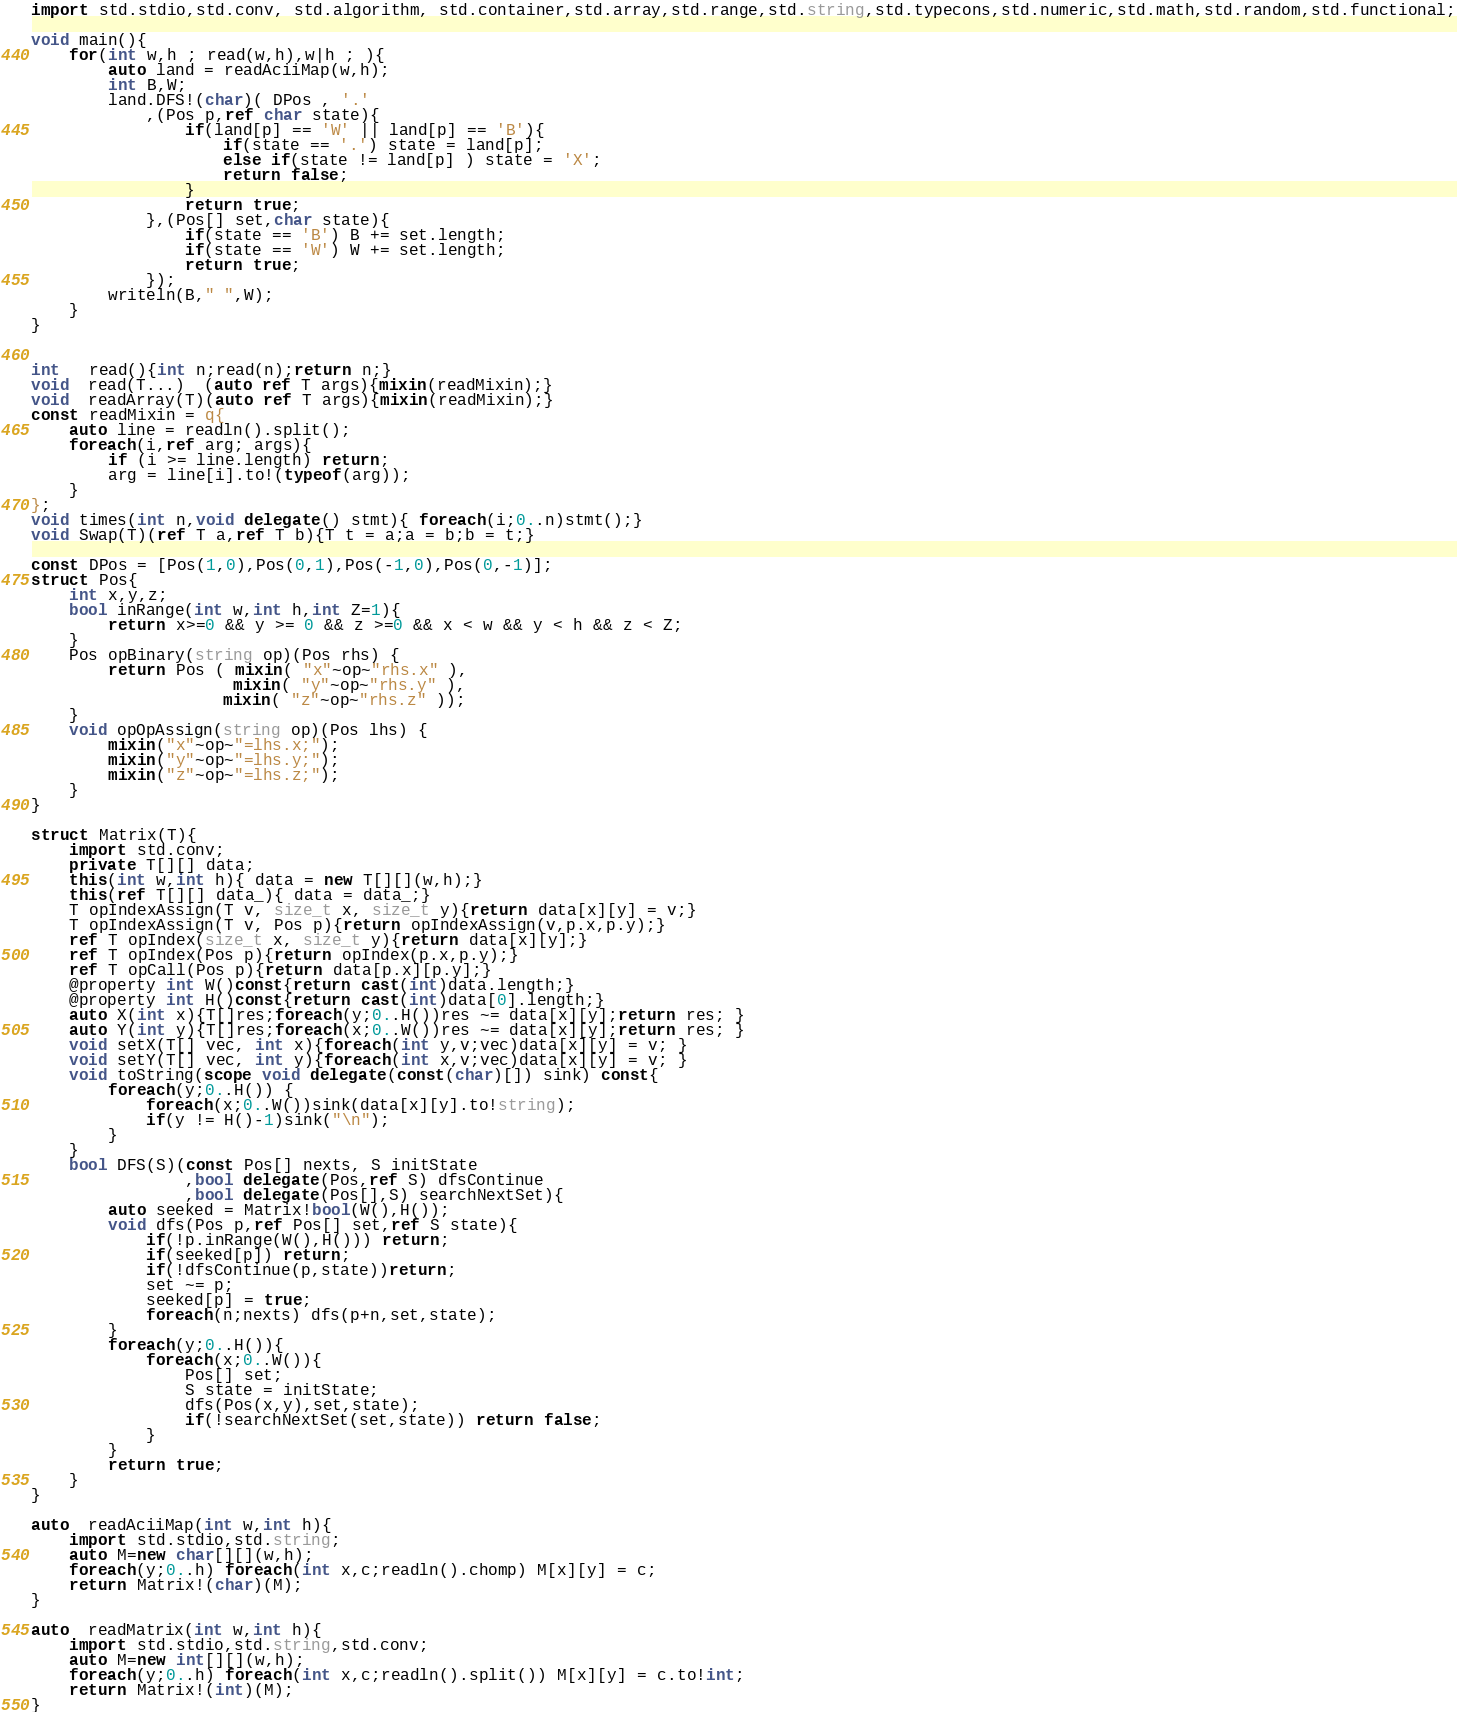Convert code to text. <code><loc_0><loc_0><loc_500><loc_500><_D_>import std.stdio,std.conv, std.algorithm, std.container,std.array,std.range,std.string,std.typecons,std.numeric,std.math,std.random,std.functional;

void main(){
	for(int w,h ; read(w,h),w|h ; ){		
		auto land = readAciiMap(w,h);
		int B,W;
		land.DFS!(char)( DPos , '.'
			,(Pos p,ref char state){
				if(land[p] == 'W' || land[p] == 'B'){
					if(state == '.') state = land[p];
					else if(state != land[p] ) state = 'X';
					return false;
				} 
				return true;
			},(Pos[] set,char state){
				if(state == 'B') B += set.length;
				if(state == 'W') W += set.length;
				return true;
			});
		writeln(B," ",W);
	}
}


int   read(){int n;read(n);return n;}
void  read(T...)  (auto ref T args){mixin(readMixin);}
void  readArray(T)(auto ref T args){mixin(readMixin);}
const readMixin = q{ 
	auto line = readln().split();
	foreach(i,ref arg; args){ 
		if (i >= line.length) return;
		arg = line[i].to!(typeof(arg));
	}
};
void times(int n,void delegate() stmt){ foreach(i;0..n)stmt();}
void Swap(T)(ref T a,ref T b){T t = a;a = b;b = t;}

const DPos = [Pos(1,0),Pos(0,1),Pos(-1,0),Pos(0,-1)];
struct Pos{ 
	int x,y,z;
	bool inRange(int w,int h,int Z=1){
		return x>=0 && y >= 0 && z >=0 && x < w && y < h && z < Z;
	}
	Pos opBinary(string op)(Pos rhs) {
		return Pos ( mixin( "x"~op~"rhs.x" ),
					 mixin( "y"~op~"rhs.y" ),
					mixin( "z"~op~"rhs.z" ));
	}
	void opOpAssign(string op)(Pos lhs) {
		mixin("x"~op~"=lhs.x;");
		mixin("y"~op~"=lhs.y;");
		mixin("z"~op~"=lhs.z;");
	}
}

struct Matrix(T){
	import std.conv;
	private T[][] data;
	this(int w,int h){ data = new T[][](w,h);}
	this(ref T[][] data_){ data = data_;}
	T opIndexAssign(T v, size_t x, size_t y){return data[x][y] = v;}
	T opIndexAssign(T v, Pos p){return opIndexAssign(v,p.x,p.y);}
	ref T opIndex(size_t x, size_t y){return data[x][y];}
	ref T opIndex(Pos p){return opIndex(p.x,p.y);}
	ref T opCall(Pos p){return data[p.x][p.y];}
	@property int W()const{return cast(int)data.length;}	
	@property int H()const{return cast(int)data[0].length;}	
	auto X(int x){T[]res;foreach(y;0..H())res ~= data[x][y];return res; }
	auto Y(int y){T[]res;foreach(x;0..W())res ~= data[x][y];return res; }
	void setX(T[] vec, int x){foreach(int y,v;vec)data[x][y] = v; }
	void setY(T[] vec, int y){foreach(int x,v;vec)data[x][y] = v; }
	void toString(scope void delegate(const(char)[]) sink) const{
		foreach(y;0..H()) {
			foreach(x;0..W())sink(data[x][y].to!string);
			if(y != H()-1)sink("\n");
		}
    }
	bool DFS(S)(const Pos[] nexts, S initState
				,bool delegate(Pos,ref S) dfsContinue
				,bool delegate(Pos[],S) searchNextSet){
		auto seeked = Matrix!bool(W(),H());
		void dfs(Pos p,ref Pos[] set,ref S state){ 
			if(!p.inRange(W(),H())) return;
			if(seeked[p]) return;
			if(!dfsContinue(p,state))return;
			set ~= p;
			seeked[p] = true;
			foreach(n;nexts) dfs(p+n,set,state);
		}
		foreach(y;0..H()){
			foreach(x;0..W()){
				Pos[] set;
				S state = initState;
				dfs(Pos(x,y),set,state);
				if(!searchNextSet(set,state)) return false;
			}
		}
		return true;
	}
}

auto  readAciiMap(int w,int h){ 
	import std.stdio,std.string;
	auto M=new char[][](w,h);
	foreach(y;0..h) foreach(int x,c;readln().chomp) M[x][y] = c;		
	return Matrix!(char)(M);
}

auto  readMatrix(int w,int h){
	import std.stdio,std.string,std.conv;
	auto M=new int[][](w,h);
	foreach(y;0..h) foreach(int x,c;readln().split()) M[x][y] = c.to!int;
	return Matrix!(int)(M);
}</code> 